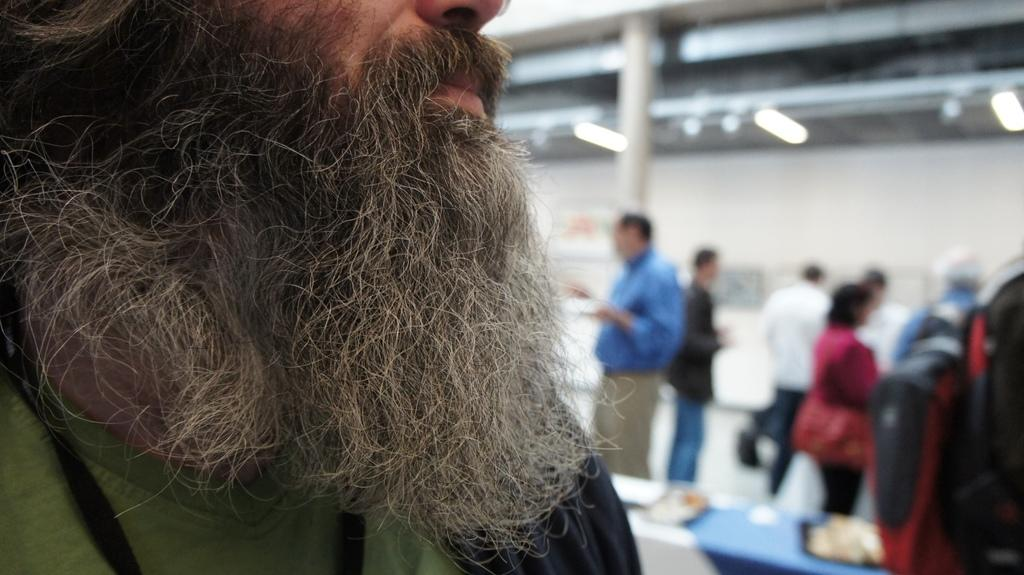How many persons are in the image? There are persons in the image. What is the main object in the image? There is a table in the image. What can be seen in the background of the image? There is a pillar, lights, and a wall in the background of the image. What type of pin is being used for punishment in the image? There is no pin or punishment present in the image. What direction is the zephyr blowing in the image? There is no zephyr present in the image. 